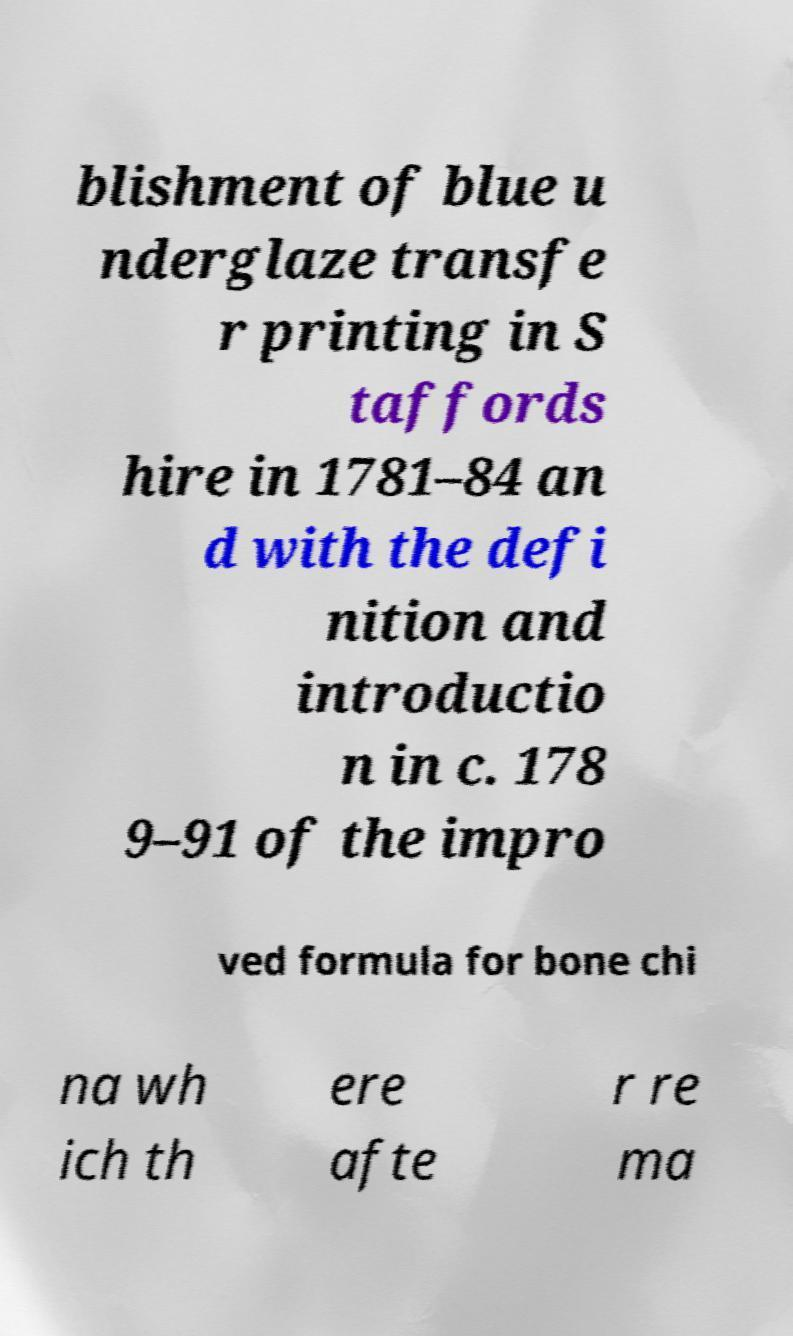Could you assist in decoding the text presented in this image and type it out clearly? blishment of blue u nderglaze transfe r printing in S taffords hire in 1781–84 an d with the defi nition and introductio n in c. 178 9–91 of the impro ved formula for bone chi na wh ich th ere afte r re ma 